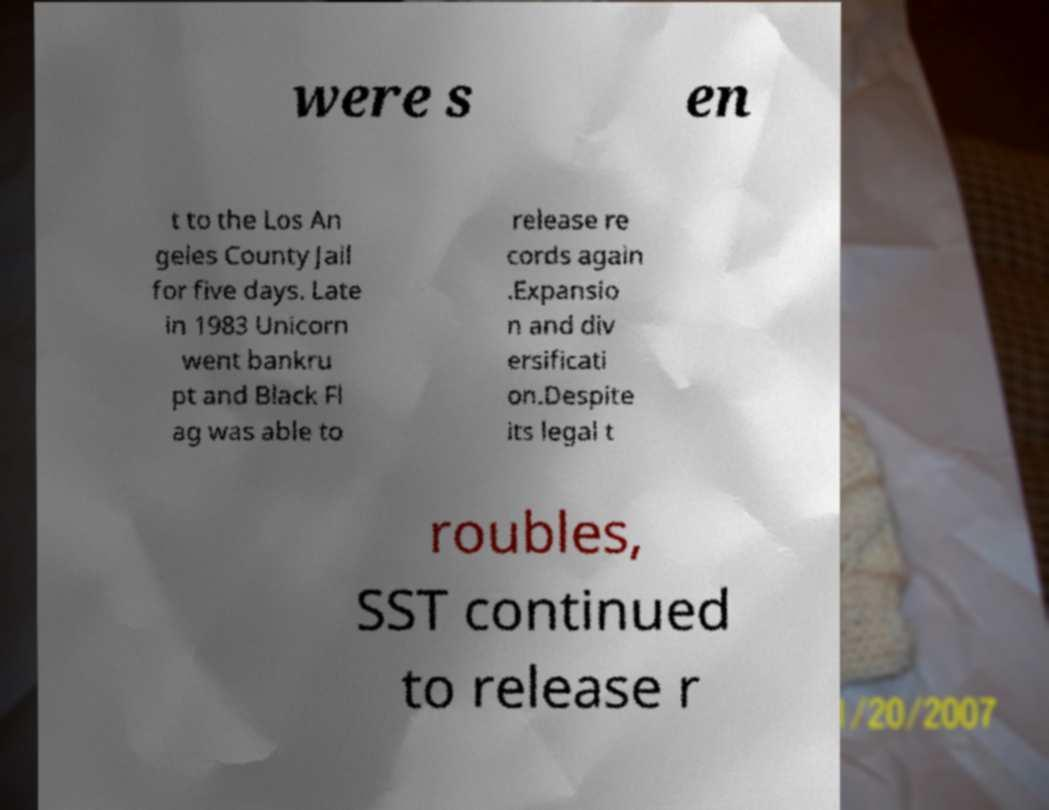Can you read and provide the text displayed in the image?This photo seems to have some interesting text. Can you extract and type it out for me? were s en t to the Los An geles County Jail for five days. Late in 1983 Unicorn went bankru pt and Black Fl ag was able to release re cords again .Expansio n and div ersificati on.Despite its legal t roubles, SST continued to release r 